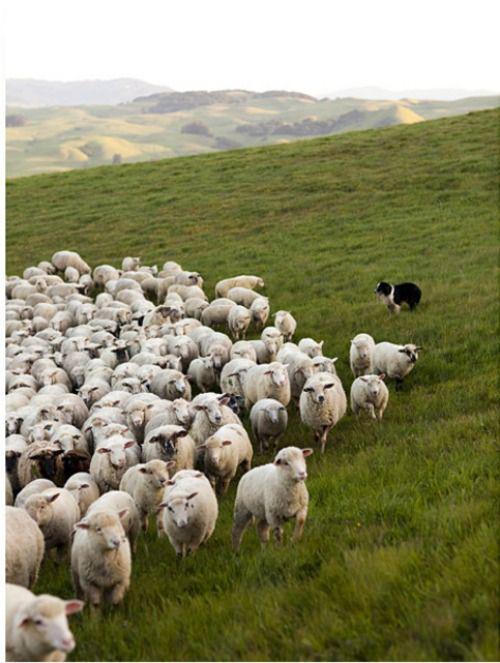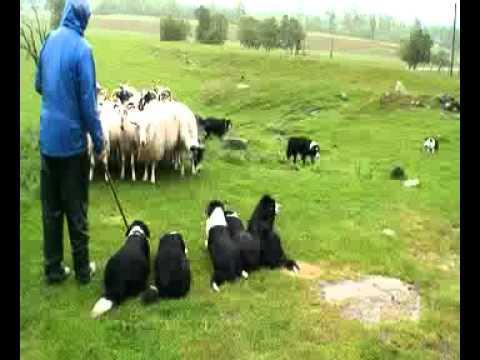The first image is the image on the left, the second image is the image on the right. For the images displayed, is the sentence "An image includes a person with just one dog." factually correct? Answer yes or no. No. The first image is the image on the left, the second image is the image on the right. Examine the images to the left and right. Is the description "In one image, a man is standing in a green, grassy area with multiple dogs and multiple sheep." accurate? Answer yes or no. Yes. 